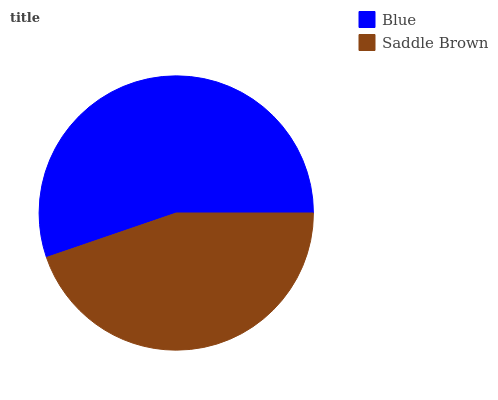Is Saddle Brown the minimum?
Answer yes or no. Yes. Is Blue the maximum?
Answer yes or no. Yes. Is Saddle Brown the maximum?
Answer yes or no. No. Is Blue greater than Saddle Brown?
Answer yes or no. Yes. Is Saddle Brown less than Blue?
Answer yes or no. Yes. Is Saddle Brown greater than Blue?
Answer yes or no. No. Is Blue less than Saddle Brown?
Answer yes or no. No. Is Blue the high median?
Answer yes or no. Yes. Is Saddle Brown the low median?
Answer yes or no. Yes. Is Saddle Brown the high median?
Answer yes or no. No. Is Blue the low median?
Answer yes or no. No. 